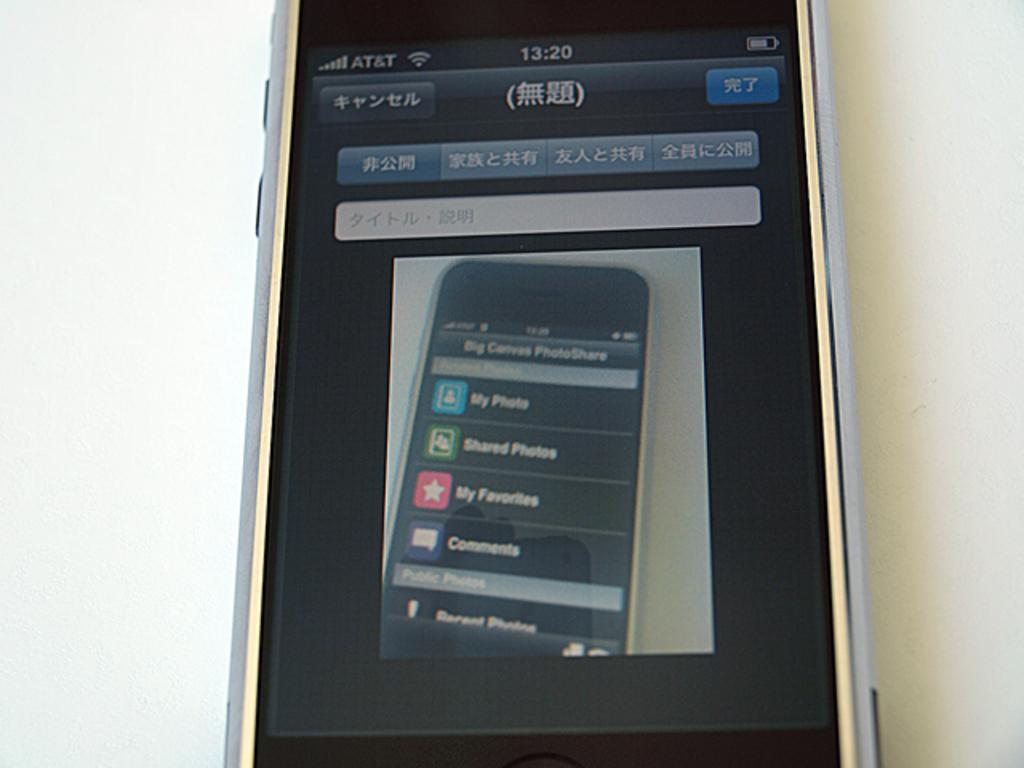What network is the phone displaying the image on?
Provide a short and direct response. At&t. 